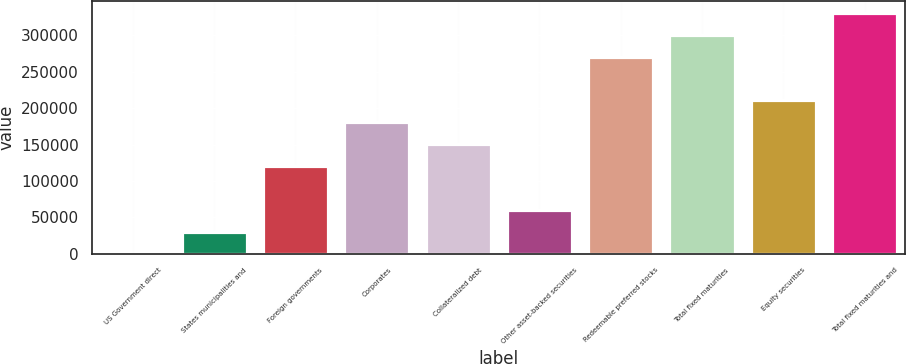<chart> <loc_0><loc_0><loc_500><loc_500><bar_chart><fcel>US Government direct<fcel>States municipalities and<fcel>Foreign governments<fcel>Corporates<fcel>Collateralized debt<fcel>Other asset-backed securities<fcel>Redeemable preferred stocks<fcel>Total fixed maturities<fcel>Equity securities<fcel>Total fixed maturities and<nl><fcel>0.21<fcel>30202.2<fcel>120808<fcel>181212<fcel>151010<fcel>60404.2<fcel>270189<fcel>300391<fcel>211414<fcel>330593<nl></chart> 